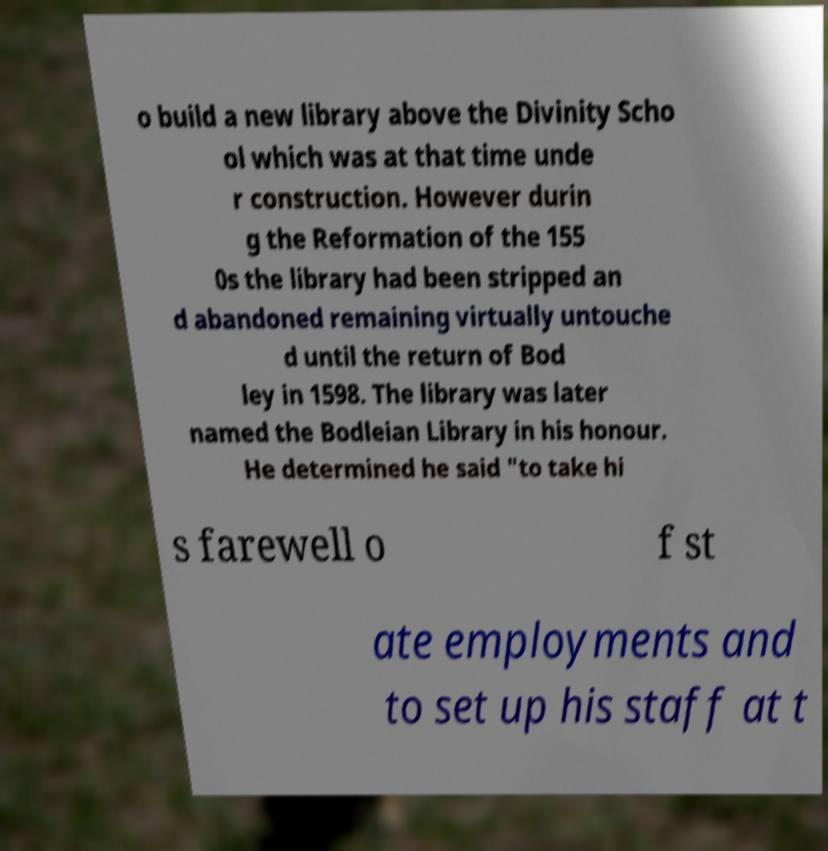Please read and relay the text visible in this image. What does it say? o build a new library above the Divinity Scho ol which was at that time unde r construction. However durin g the Reformation of the 155 0s the library had been stripped an d abandoned remaining virtually untouche d until the return of Bod ley in 1598. The library was later named the Bodleian Library in his honour. He determined he said "to take hi s farewell o f st ate employments and to set up his staff at t 